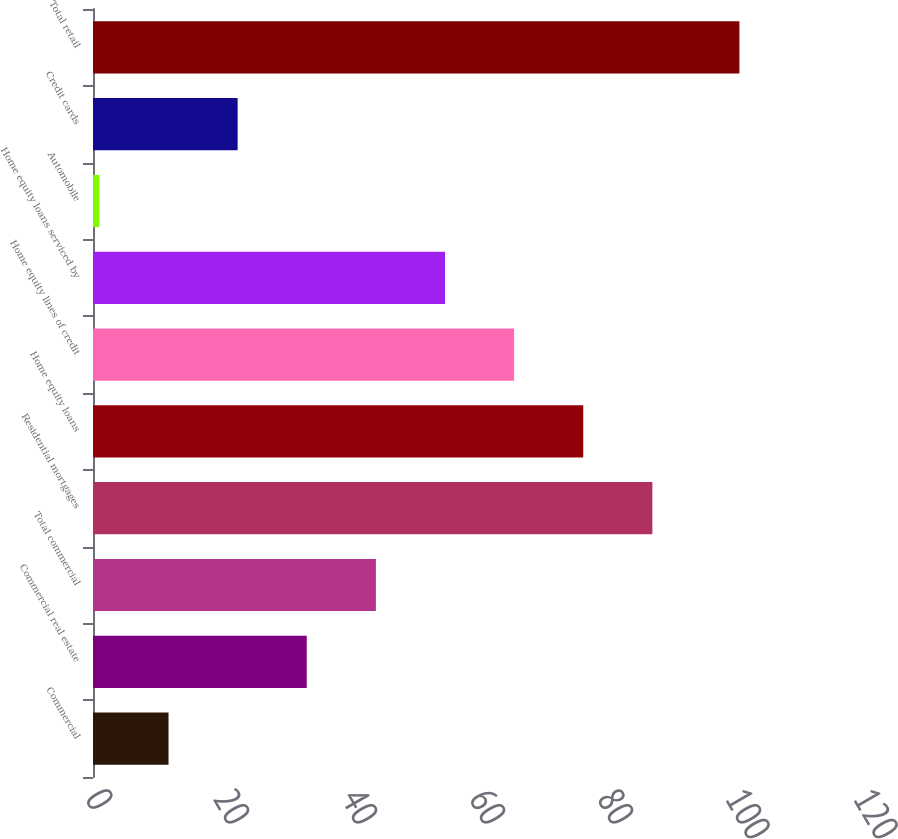<chart> <loc_0><loc_0><loc_500><loc_500><bar_chart><fcel>Commercial<fcel>Commercial real estate<fcel>Total commercial<fcel>Residential mortgages<fcel>Home equity loans<fcel>Home equity lines of credit<fcel>Home equity loans serviced by<fcel>Automobile<fcel>Credit cards<fcel>Total retail<nl><fcel>11.8<fcel>33.4<fcel>44.2<fcel>87.4<fcel>76.6<fcel>65.8<fcel>55<fcel>1<fcel>22.6<fcel>101<nl></chart> 